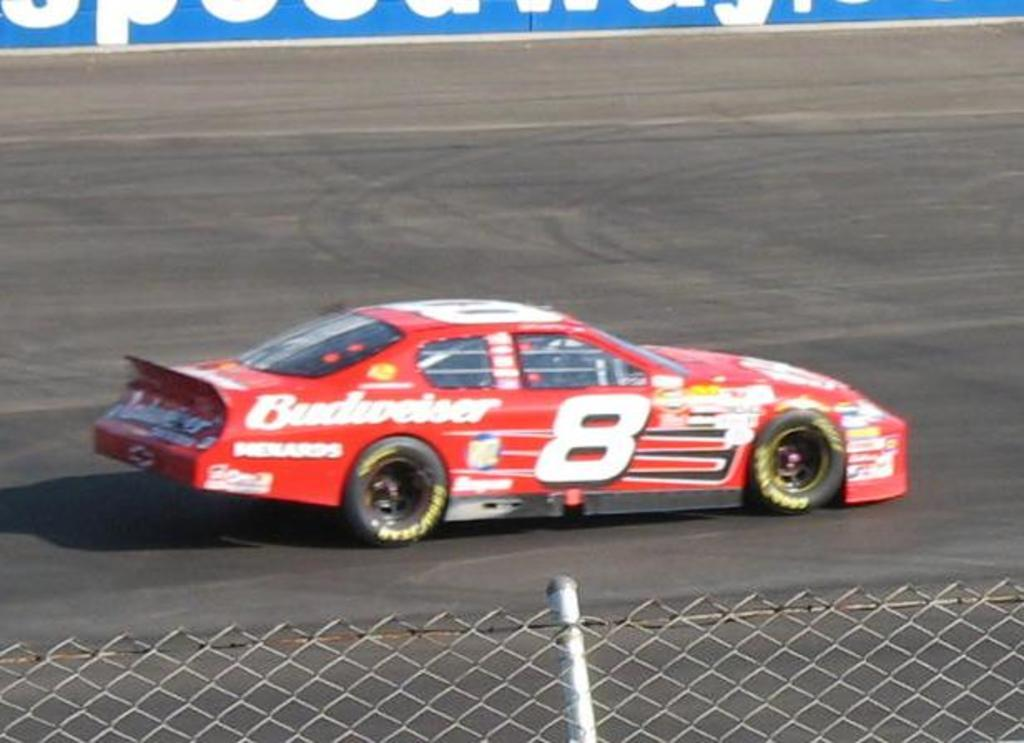What is the main subject of the image? The main subject of the image is a car. Can you describe the car in the image? The car is red. What is located at the bottom of the image? There is a fence at the bottom of the image. How many dolls are sitting inside the car in the image? There are no dolls present in the image. What type of muscle is visible on the car in the image? Cars do not have muscles; they have engines and other mechanical components. 